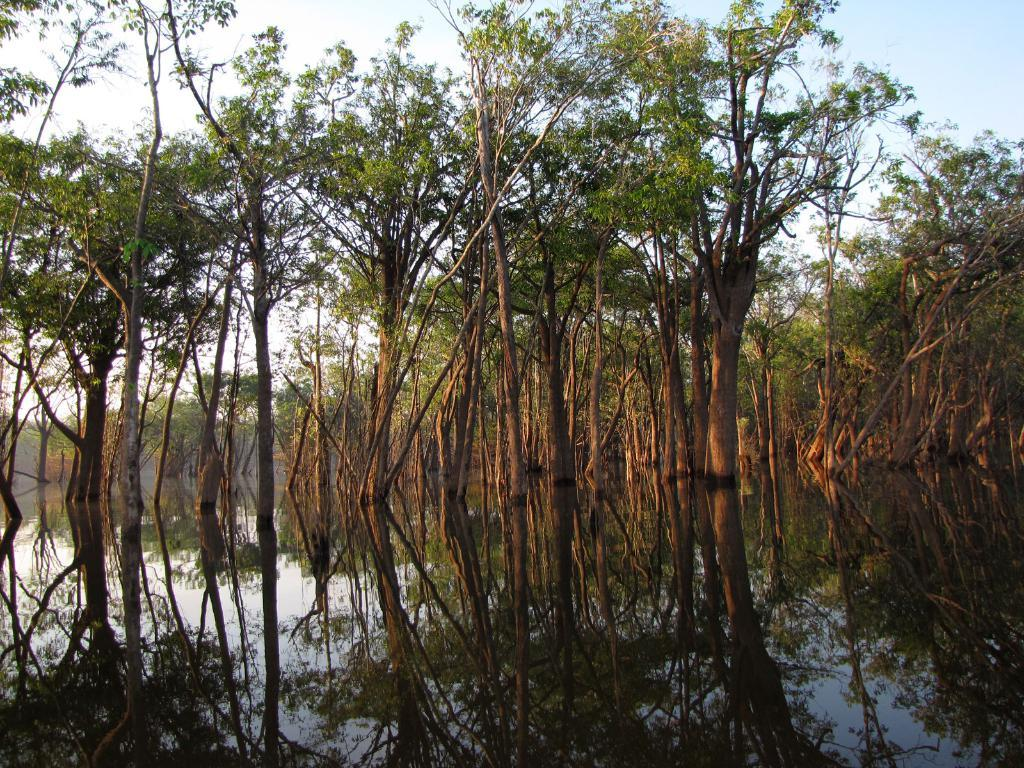What type of vegetation can be seen in the image? There are trees in the image. What natural element is also visible in the image? There is water visible in the image. Can you describe the ornament on the stranger's wrist in the image? There is no stranger or ornament present in the image; it only features trees and water. 